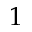<formula> <loc_0><loc_0><loc_500><loc_500>1</formula> 